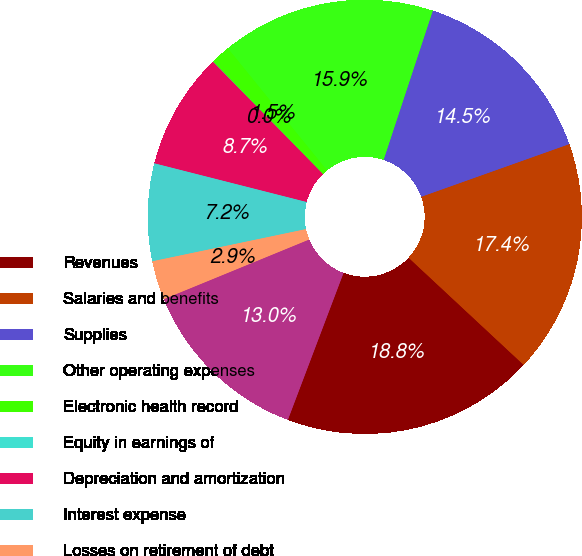Convert chart to OTSL. <chart><loc_0><loc_0><loc_500><loc_500><pie_chart><fcel>Revenues<fcel>Salaries and benefits<fcel>Supplies<fcel>Other operating expenses<fcel>Electronic health record<fcel>Equity in earnings of<fcel>Depreciation and amortization<fcel>Interest expense<fcel>Losses on retirement of debt<fcel>Income before income taxes<nl><fcel>18.83%<fcel>17.38%<fcel>14.49%<fcel>15.93%<fcel>1.46%<fcel>0.02%<fcel>8.7%<fcel>7.25%<fcel>2.91%<fcel>13.04%<nl></chart> 